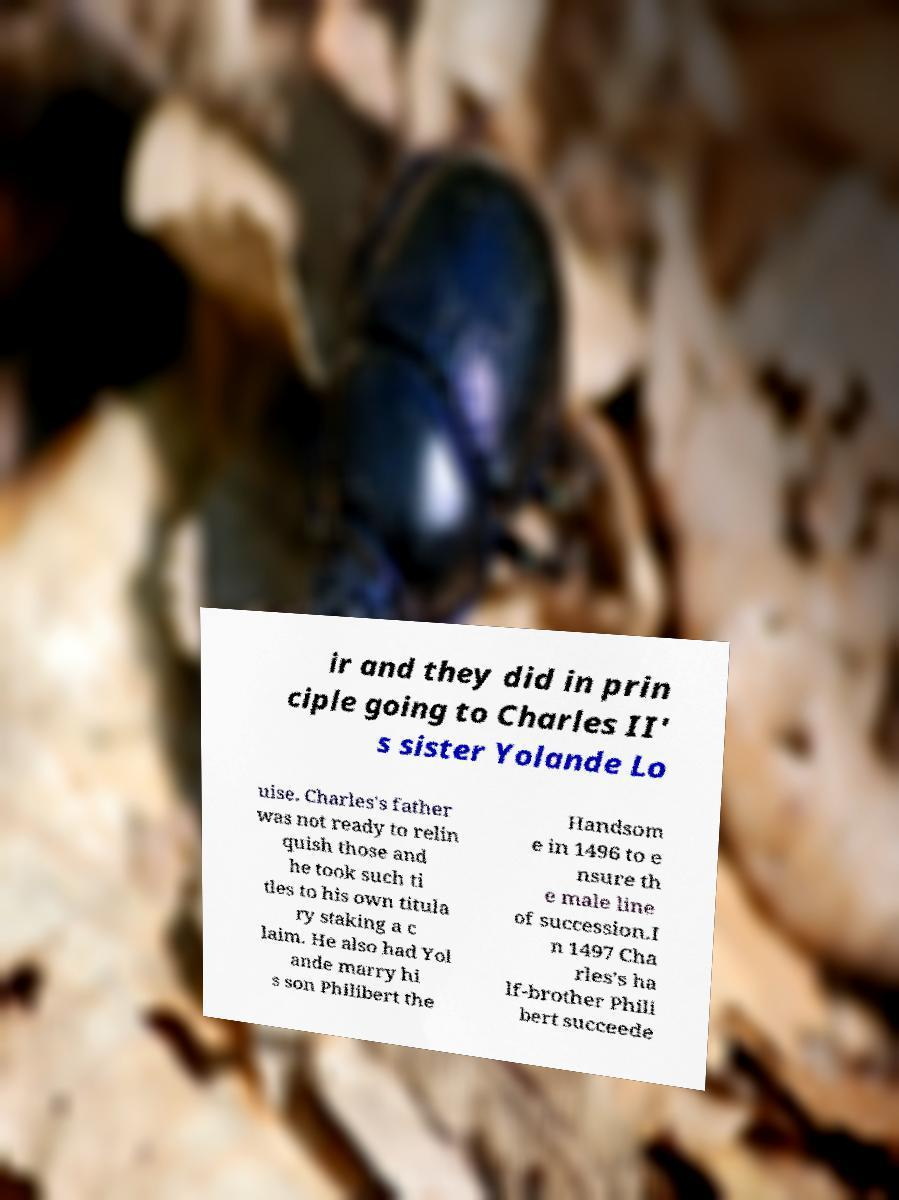There's text embedded in this image that I need extracted. Can you transcribe it verbatim? ir and they did in prin ciple going to Charles II' s sister Yolande Lo uise. Charles's father was not ready to relin quish those and he took such ti tles to his own titula ry staking a c laim. He also had Yol ande marry hi s son Philibert the Handsom e in 1496 to e nsure th e male line of succession.I n 1497 Cha rles's ha lf-brother Phili bert succeede 